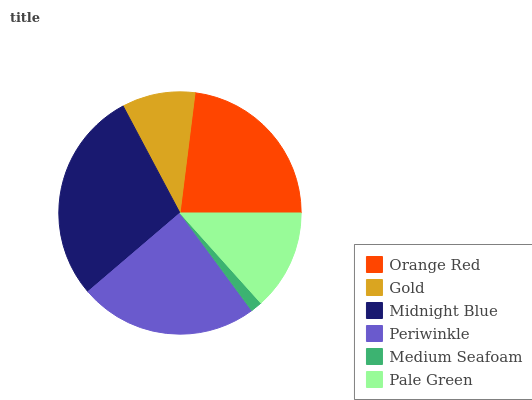Is Medium Seafoam the minimum?
Answer yes or no. Yes. Is Midnight Blue the maximum?
Answer yes or no. Yes. Is Gold the minimum?
Answer yes or no. No. Is Gold the maximum?
Answer yes or no. No. Is Orange Red greater than Gold?
Answer yes or no. Yes. Is Gold less than Orange Red?
Answer yes or no. Yes. Is Gold greater than Orange Red?
Answer yes or no. No. Is Orange Red less than Gold?
Answer yes or no. No. Is Orange Red the high median?
Answer yes or no. Yes. Is Pale Green the low median?
Answer yes or no. Yes. Is Pale Green the high median?
Answer yes or no. No. Is Periwinkle the low median?
Answer yes or no. No. 